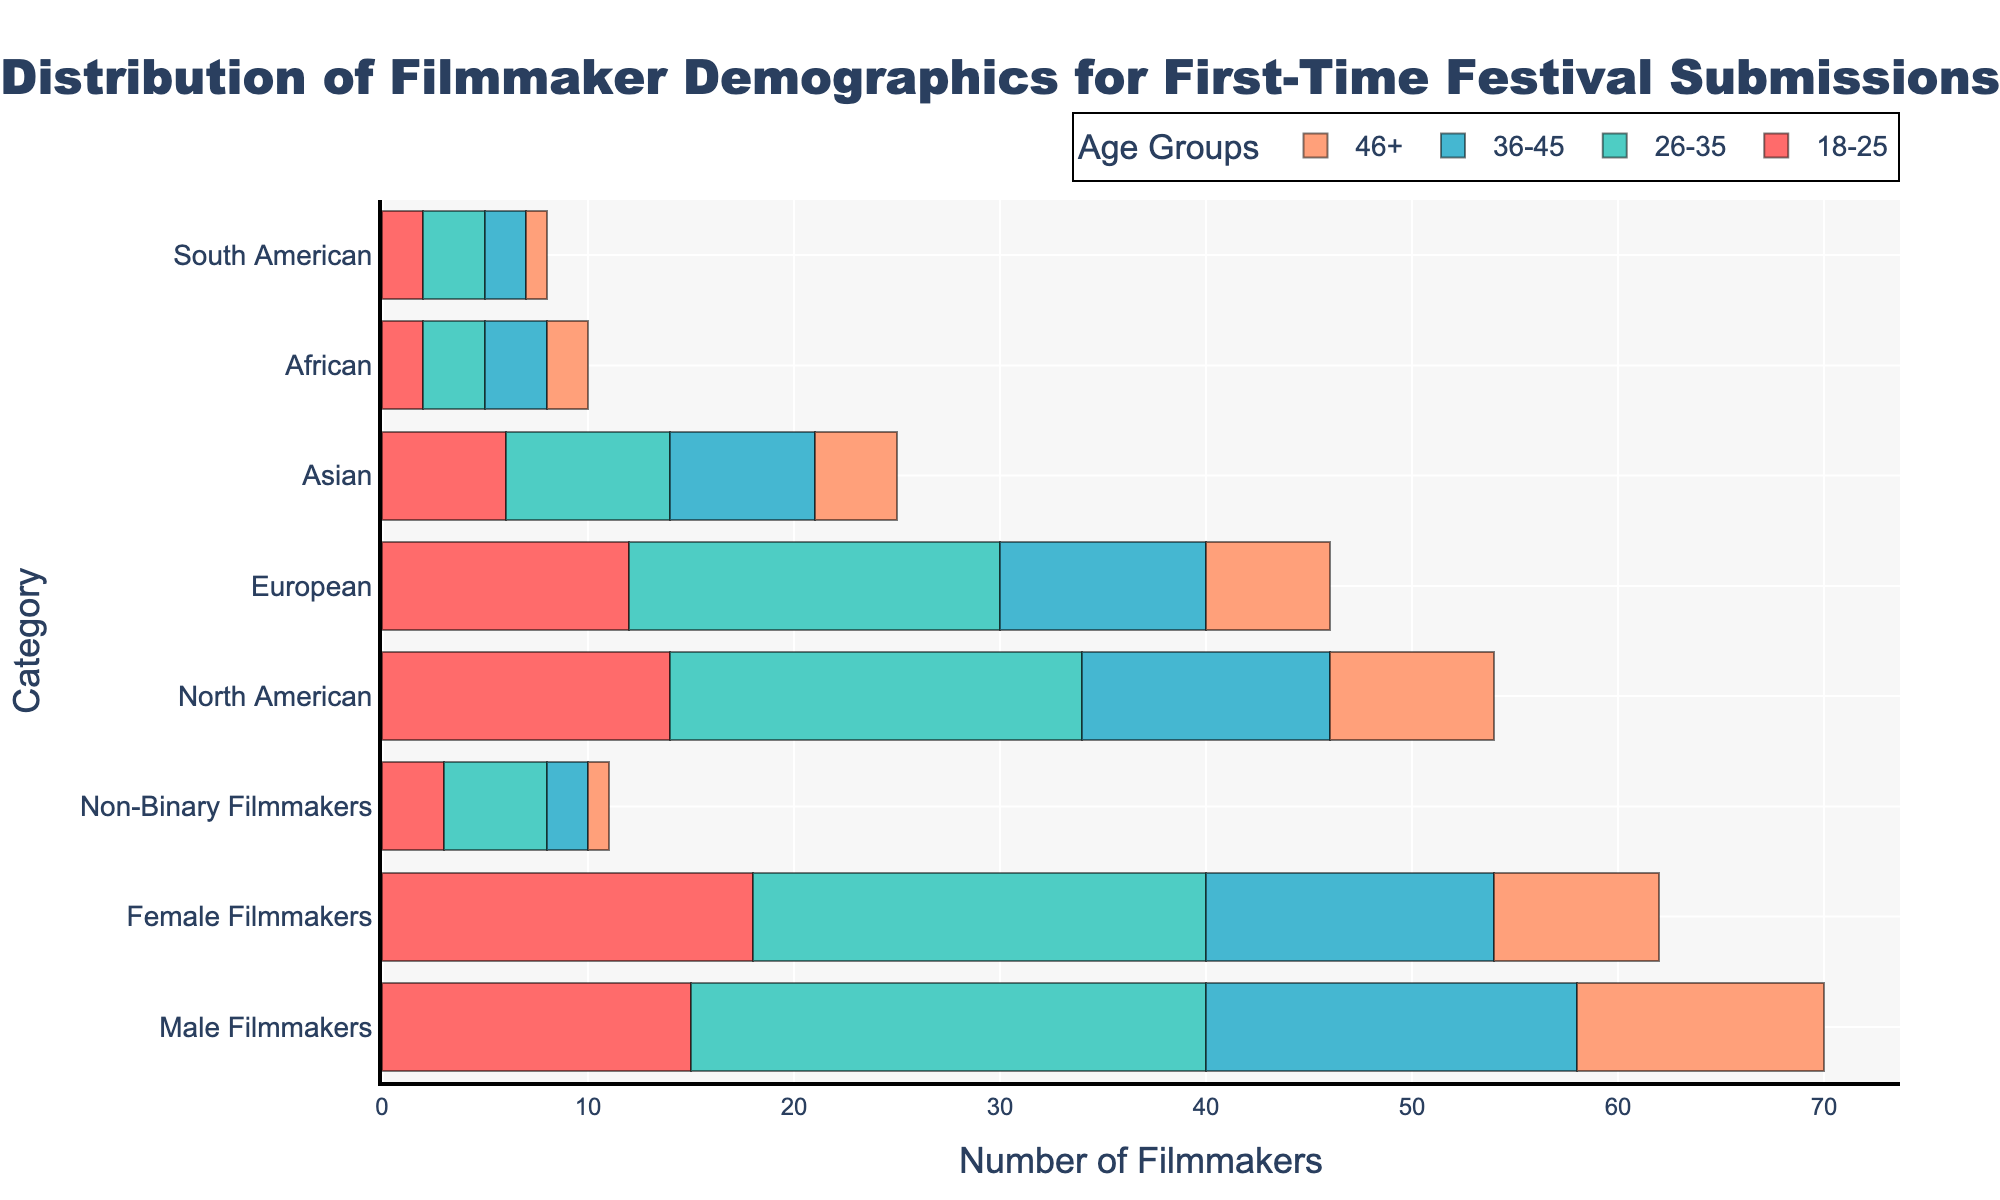what is the title of the plot? The title is located at the top center of the plot. It usually describes what the figure is about. The title here is "Distribution of Filmmaker Demographics for First-Time Festival Submissions."
Answer: Distribution of Filmmaker Demographics for First-Time Festival Submissions How many female filmmakers are there in the 26-35 age group? Look at the category labeled "Female Filmmakers" and check the value corresponding to the "26-35" age group. The number shown for this group is 22.
Answer: 22 What is the total number of filmmakers in the 46+ age group across all demographics? Sum the number of filmmakers across all categories for the "46+" age group. This includes Male (12), Female (8), and Non-Binary (1) filmmakers. The total is 12 + 8 + 1 = 21.
Answer: 21 Which age group has the highest number of North American filmmakers? Check the bars for "North American" filmmakers across all age groups. The highest value is in the "26-35" age group, which is 20.
Answer: 26-35 How does the number of female filmmakers in the 18-25 age group compare to male filmmakers in the same age group? Look at the values for "Female Filmmakers" and "Male Filmmakers" in the "18-25" age group. Females are 18, and males are 15. Females have more filmmakers in this age group.
Answer: Female filmmakers have more, with 18 compared to 15 males What's the total number of European filmmakers in all age groups? Add the number of European filmmakers across all age groups: 18-25 (12), 26-35 (18), 36-45 (10), and 46+ (6). This gives a total of 12 + 18 + 10 + 6 = 46.
Answer: 46 Compare the number of non-binary filmmakers in the 36-45 age group with those in the 46+ age group. Look at the "Non-Binary Filmmakers" category and compare the values for the "36-45" (2) and "46+" (1) age groups. There are more non-binary filmmakers in the 36-45 group compared to the 46+ group.
Answer: 36-45 has more with 2, while 46+ has 1 Which category has the least total number of filmmakers in all age groups? Sum the number of filmmakers in each category across all age groups and find the minimum. The "South American" category has the least: 18-25 (2), 26-35 (3), 36-45 (2), and 46+ (1). The total is 2 + 3 + 2 + 1 = 8.
Answer: South American filmmakers What is the distribution of filmmakers in the 18-25 age group across different genders? Examine the quantities for male, female, and non-binary filmmakers in the "18-25" age group. Males: 15, Females: 18, Non-Binary: 3.
Answer: Males: 15, Females: 18, Non-Binary: 3 How many more filmmakers are there in the 26-35 age group compared to the 46+ age group? Sum the number of filmmakers across all categories for the age group "26-35" and for "46+". Then subtract the total of the "46+" group from the "26-35" group. (25 + 22 + 5 + 20 + 18 + 8 + 3 + 3) - (12 + 8 + 1 + 8 + 6 + 4 + 2 + 1) = 104 - 42 = 62.
Answer: 62 